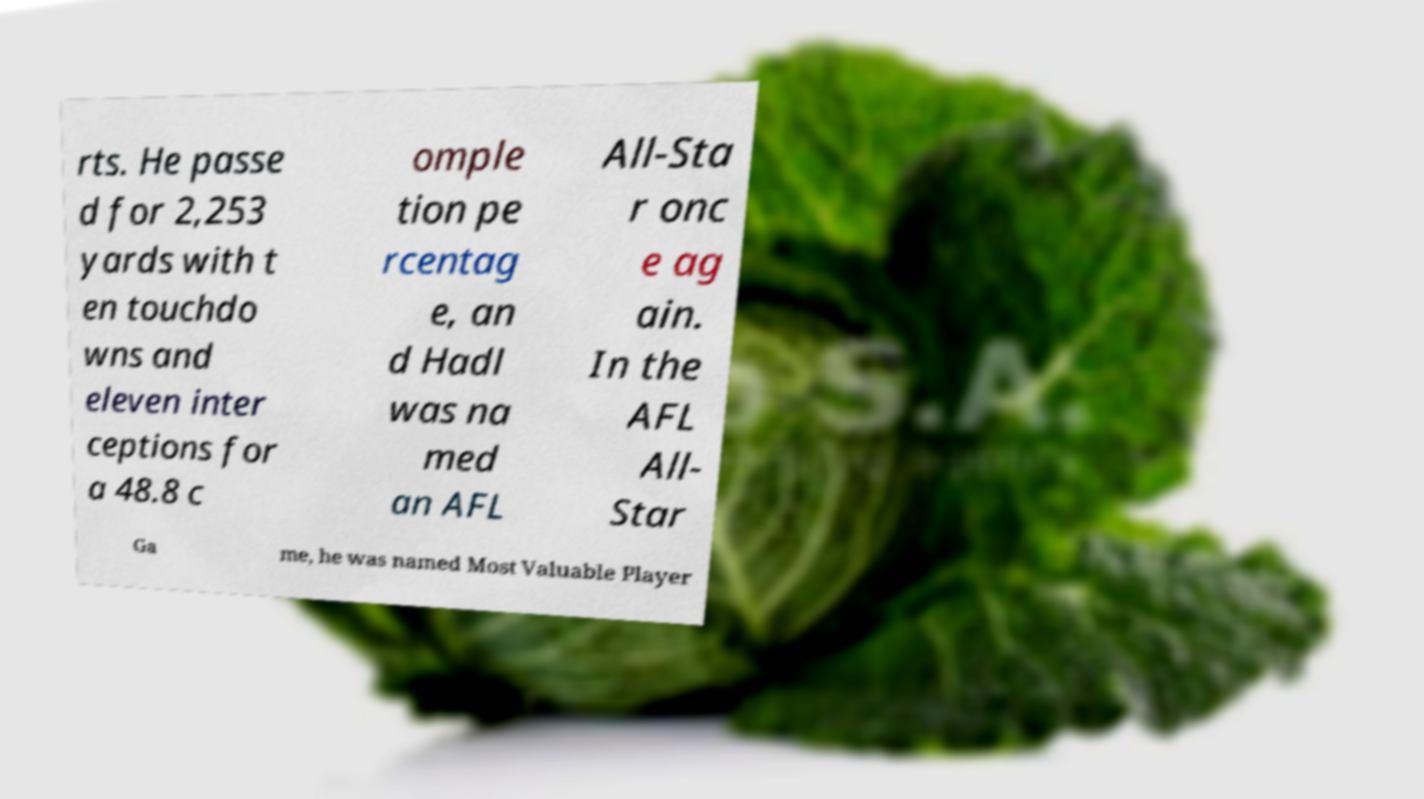Can you accurately transcribe the text from the provided image for me? rts. He passe d for 2,253 yards with t en touchdo wns and eleven inter ceptions for a 48.8 c omple tion pe rcentag e, an d Hadl was na med an AFL All-Sta r onc e ag ain. In the AFL All- Star Ga me, he was named Most Valuable Player 